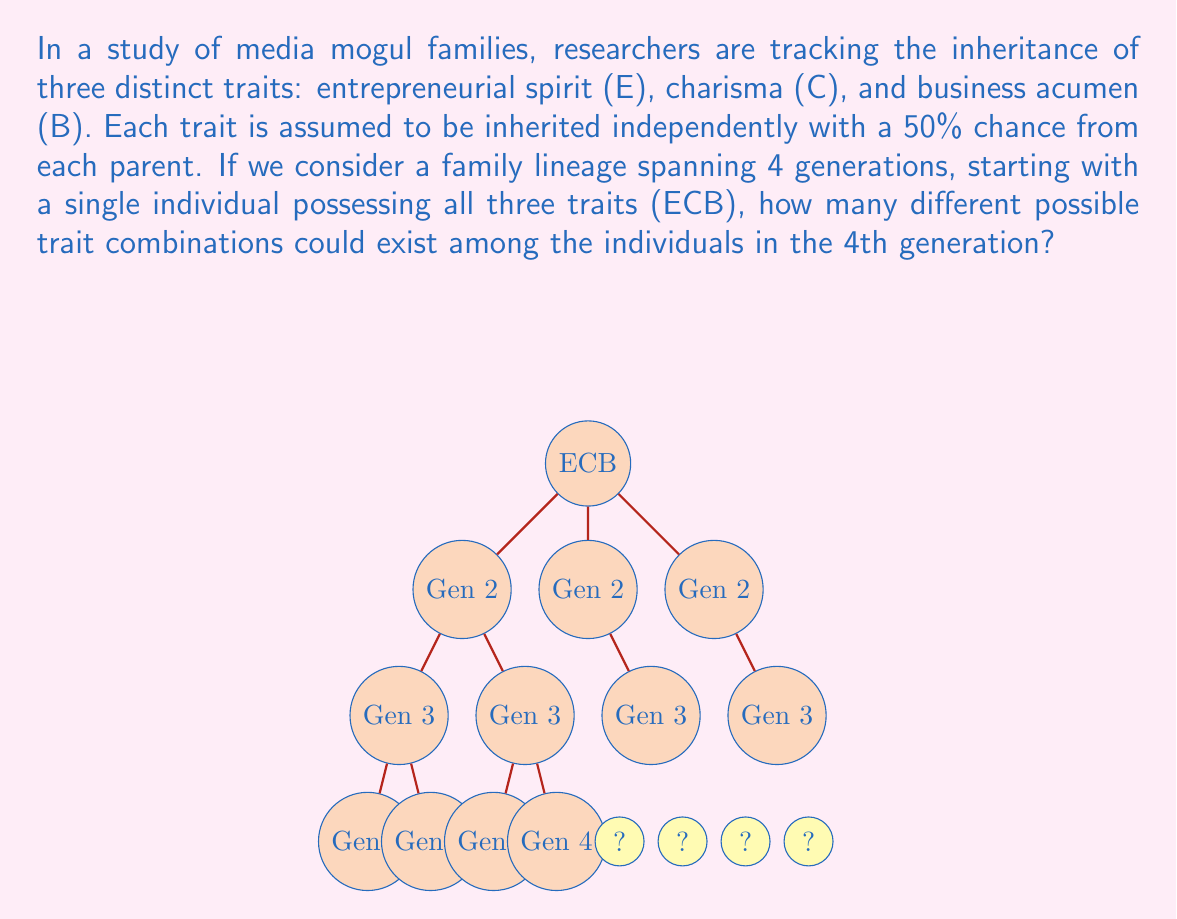Give your solution to this math problem. Let's approach this step-by-step:

1) First, we need to understand that for each trait, an individual in the 4th generation has two possibilities: either they have the trait or they don't. This is because the trait is inherited with a 50% chance from each parent.

2) Since there are three independent traits (E, C, B), we can use the multiplication principle of combinatorics.

3) For each trait, there are 2 possibilities (present or absent). Therefore, for all three traits, the total number of possible combinations is:

   $2 \times 2 \times 2 = 2^3 = 8$

4) This means that for any individual in the 4th generation, there are 8 possible trait combinations:
   - No traits (---) 
   - Only E (E--)
   - Only C (-C-)
   - Only B (--B)
   - E and C (EC-)
   - E and B (E-B)
   - C and B (-CB)
   - All traits (ECB)

5) It's important to note that the question asks about the possible combinations in the 4th generation, not the probability of each combination occurring.

6) The inheritance pattern of previous generations doesn't affect the possible combinations in the 4th generation. Even if some combinations were not present in the 3rd generation, they could potentially appear in the 4th due to genetic recombination.

Therefore, regardless of the inheritance patterns in the intermediate generations, there are always 8 possible trait combinations for individuals in the 4th generation.
Answer: $2^3 = 8$ combinations 